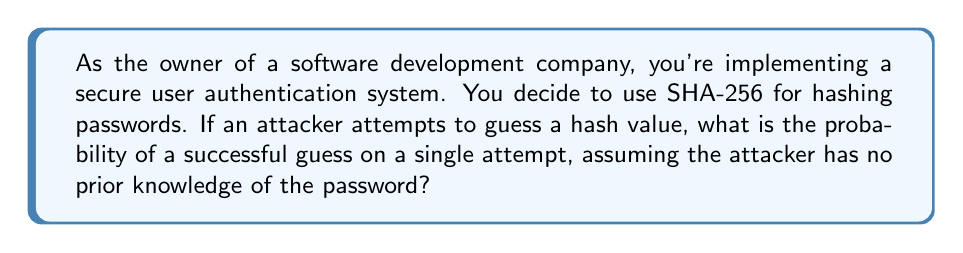Help me with this question. Let's approach this step-by-step:

1) SHA-256 produces a 256-bit hash value.

2) For each bit, there are 2 possible values (0 or 1).

3) Therefore, the total number of possible hash values is:

   $$2^{256}$$

4) The probability of guessing the correct hash is the same as guessing one specific value out of all possible values:

   $$P(\text{correct guess}) = \frac{1}{\text{total number of possible values}}$$

5) Substituting our value:

   $$P(\text{correct guess}) = \frac{1}{2^{256}}$$

6) This probability is extremely small. To put it in perspective:

   $$\frac{1}{2^{256}} \approx 8.636 \times 10^{-78}$$

This means that the chance of guessing the correct hash on a single attempt is virtually zero, demonstrating the security of SHA-256 against brute-force attacks.
Answer: $\frac{1}{2^{256}}$ 